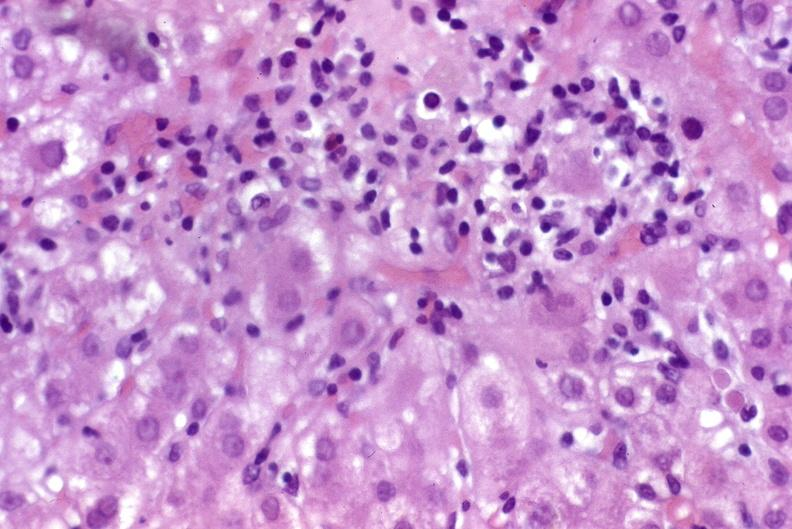what is present?
Answer the question using a single word or phrase. Hepatobiliary 